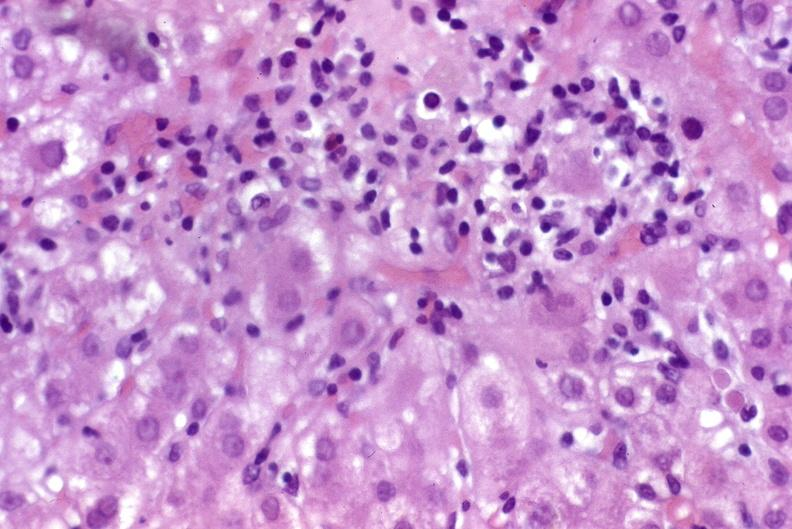what is present?
Answer the question using a single word or phrase. Hepatobiliary 